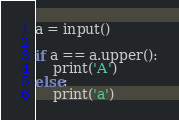<code> <loc_0><loc_0><loc_500><loc_500><_Python_>a = input()

if a == a.upper():
    print('A')
else:
    print('a')
</code> 